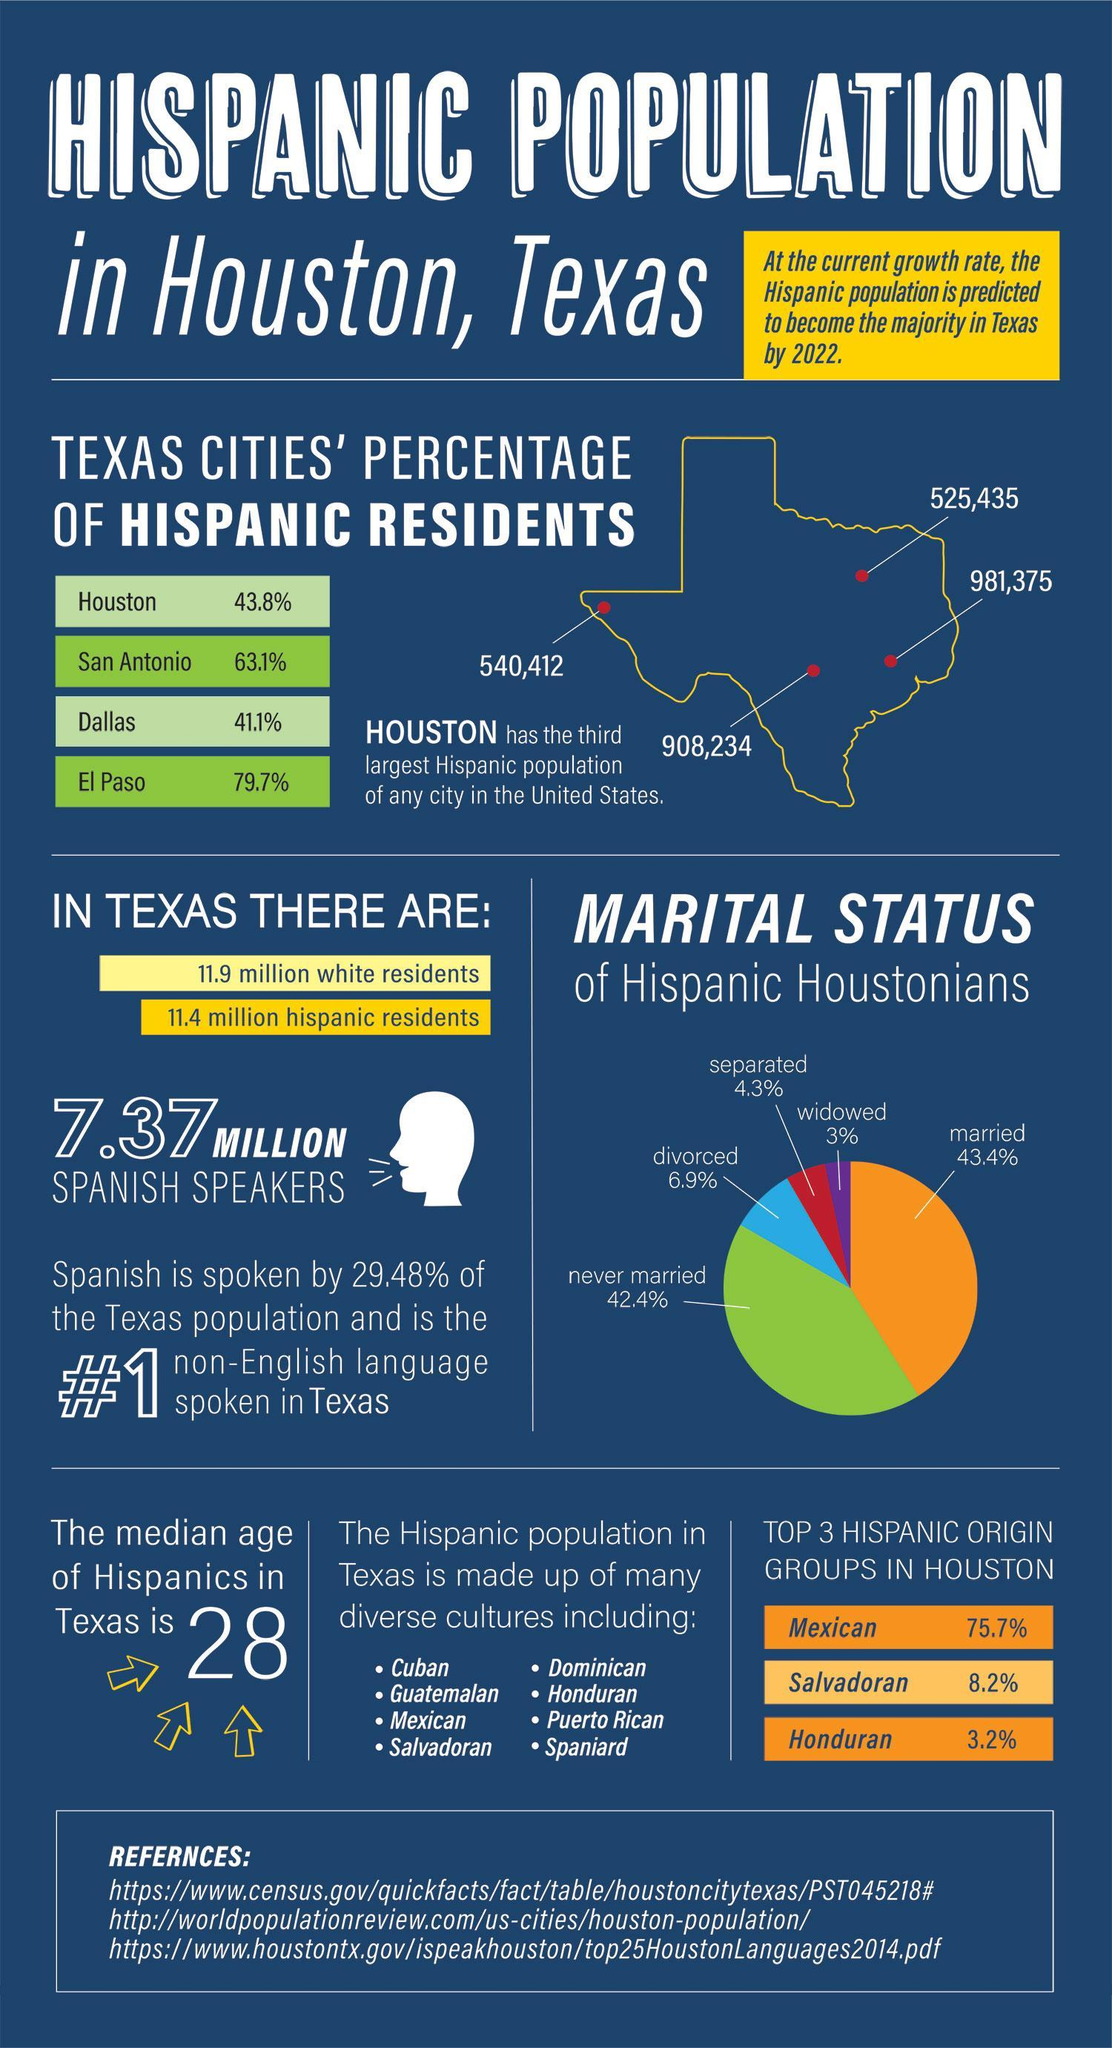What is the total percentage of Hispanics with the marital status single?
Answer the question with a short phrase. 14.2% What is the percentage difference between married and unmarried Hispanics in Houston? 1% Which city in Texas has the highest percentage of Hispanics? El Paso Which city in Texas has the highest number of population? Houston 